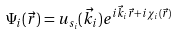<formula> <loc_0><loc_0><loc_500><loc_500>\Psi _ { i } ( \vec { r } ) = u _ { s _ { i } } ( \vec { k _ { i } } ) e ^ { i \vec { k } _ { i } \vec { r } + i \chi _ { i } ( \vec { r } ) }</formula> 